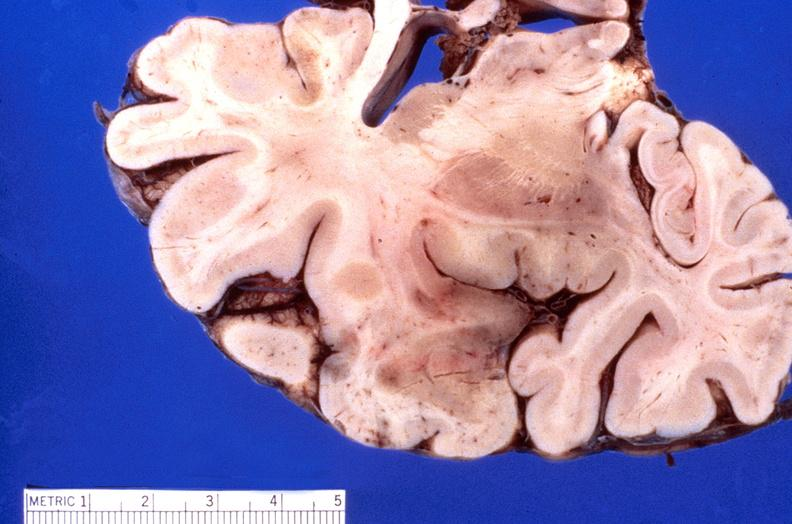s atrophy secondary to pituitectomy present?
Answer the question using a single word or phrase. No 